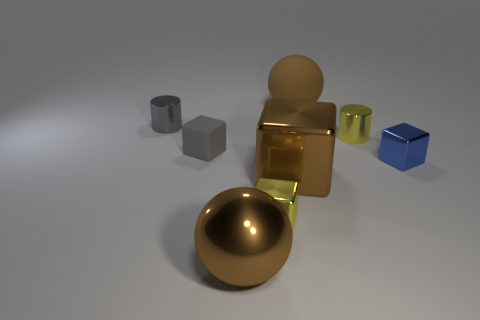What number of objects are behind the brown metal block?
Provide a succinct answer. 5. Does the big shiny cube have the same color as the large metallic sphere?
Make the answer very short. Yes. What shape is the brown thing that is the same material as the gray cube?
Provide a short and direct response. Sphere. There is a small blue object to the right of the large brown matte sphere; is it the same shape as the small rubber thing?
Provide a short and direct response. Yes. What number of gray things are either cubes or tiny cylinders?
Your answer should be very brief. 2. Are there an equal number of small shiny objects in front of the big brown metal block and tiny shiny blocks that are in front of the rubber cube?
Offer a very short reply. No. There is a shiny thing on the right side of the small metal cylinder that is on the right side of the shiny cylinder that is on the left side of the tiny rubber cube; what is its color?
Your response must be concise. Blue. Is there anything else that is the same color as the big matte thing?
Ensure brevity in your answer.  Yes. There is a thing that is the same color as the rubber cube; what is its shape?
Offer a terse response. Cylinder. There is a yellow object in front of the small blue object; what size is it?
Your response must be concise. Small. 